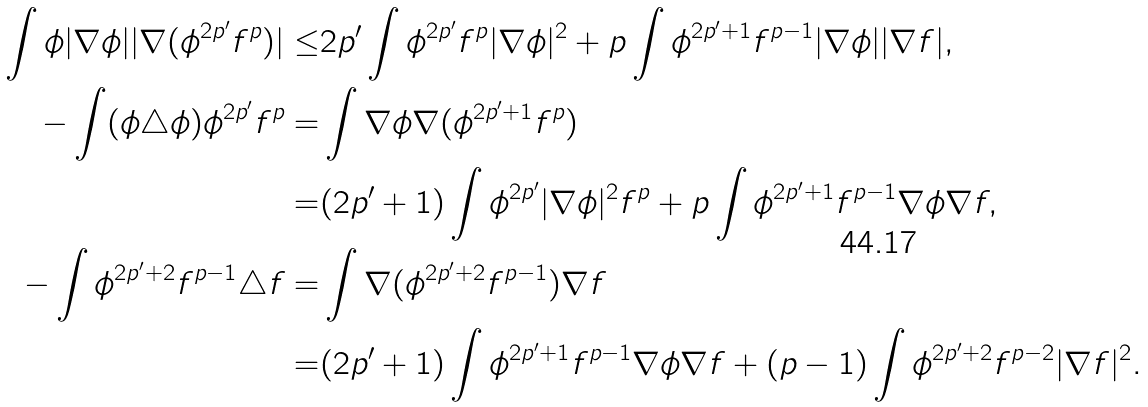<formula> <loc_0><loc_0><loc_500><loc_500>\int \phi | \nabla \phi | | \nabla ( \phi ^ { 2 p ^ { \prime } } f ^ { p } ) | \leq & 2 p ^ { \prime } \int \phi ^ { 2 p ^ { \prime } } f ^ { p } | \nabla \phi | ^ { 2 } + p \int \phi ^ { 2 p ^ { \prime } + 1 } f ^ { p - 1 } | \nabla \phi | | \nabla f | , \\ - \int ( \phi \triangle \phi ) \phi ^ { 2 p ^ { \prime } } f ^ { p } = & \int \nabla \phi \nabla ( \phi ^ { 2 p ^ { \prime } + 1 } f ^ { p } ) \\ = & ( 2 p ^ { \prime } + 1 ) \int \phi ^ { 2 p ^ { \prime } } | \nabla \phi | ^ { 2 } f ^ { p } + p \int \phi ^ { 2 p ^ { \prime } + 1 } f ^ { p - 1 } \nabla \phi \nabla f , \\ - \int \phi ^ { 2 p ^ { \prime } + 2 } f ^ { p - 1 } \triangle f = & \int \nabla ( \phi ^ { 2 p ^ { \prime } + 2 } f ^ { p - 1 } ) \nabla f \\ = & ( 2 p ^ { \prime } + 1 ) \int \phi ^ { 2 p ^ { \prime } + 1 } f ^ { p - 1 } \nabla \phi \nabla f + ( p - 1 ) \int \phi ^ { 2 p ^ { \prime } + 2 } f ^ { p - 2 } | \nabla f | ^ { 2 } .</formula> 